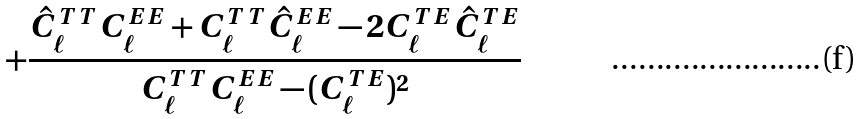Convert formula to latex. <formula><loc_0><loc_0><loc_500><loc_500>+ \frac { \hat { C } _ { \ell } ^ { T T } C _ { \ell } ^ { E E } + C _ { \ell } ^ { T T } \hat { C } _ { \ell } ^ { E E } - 2 C _ { \ell } ^ { T E } \hat { C } _ { \ell } ^ { T E } } { C _ { \ell } ^ { T T } C _ { \ell } ^ { E E } - ( C _ { \ell } ^ { T E } ) ^ { 2 } }</formula> 